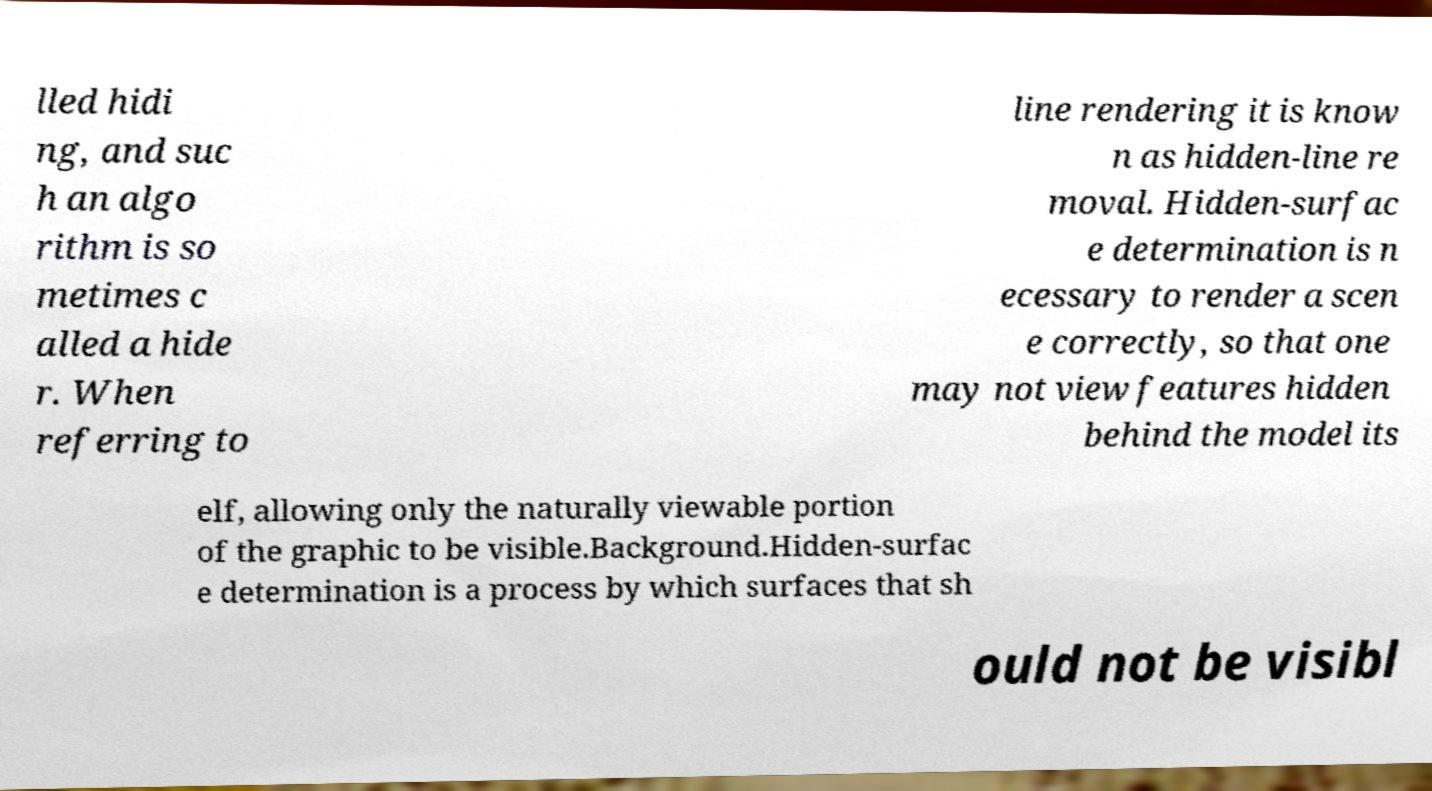Please read and relay the text visible in this image. What does it say? lled hidi ng, and suc h an algo rithm is so metimes c alled a hide r. When referring to line rendering it is know n as hidden-line re moval. Hidden-surfac e determination is n ecessary to render a scen e correctly, so that one may not view features hidden behind the model its elf, allowing only the naturally viewable portion of the graphic to be visible.Background.Hidden-surfac e determination is a process by which surfaces that sh ould not be visibl 